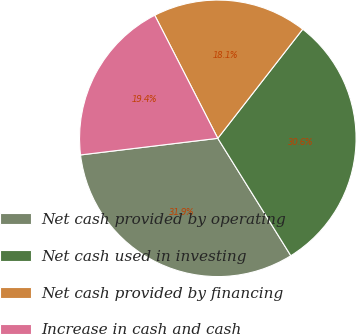Convert chart to OTSL. <chart><loc_0><loc_0><loc_500><loc_500><pie_chart><fcel>Net cash provided by operating<fcel>Net cash used in investing<fcel>Net cash provided by financing<fcel>Increase in cash and cash<nl><fcel>31.94%<fcel>30.62%<fcel>18.06%<fcel>19.38%<nl></chart> 